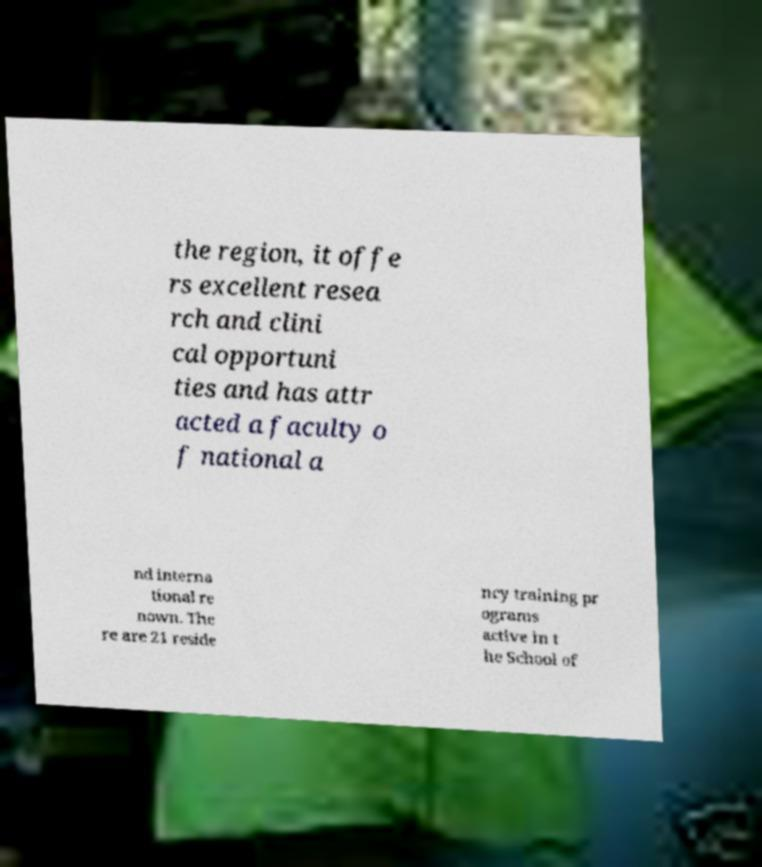There's text embedded in this image that I need extracted. Can you transcribe it verbatim? the region, it offe rs excellent resea rch and clini cal opportuni ties and has attr acted a faculty o f national a nd interna tional re nown. The re are 21 reside ncy training pr ograms active in t he School of 